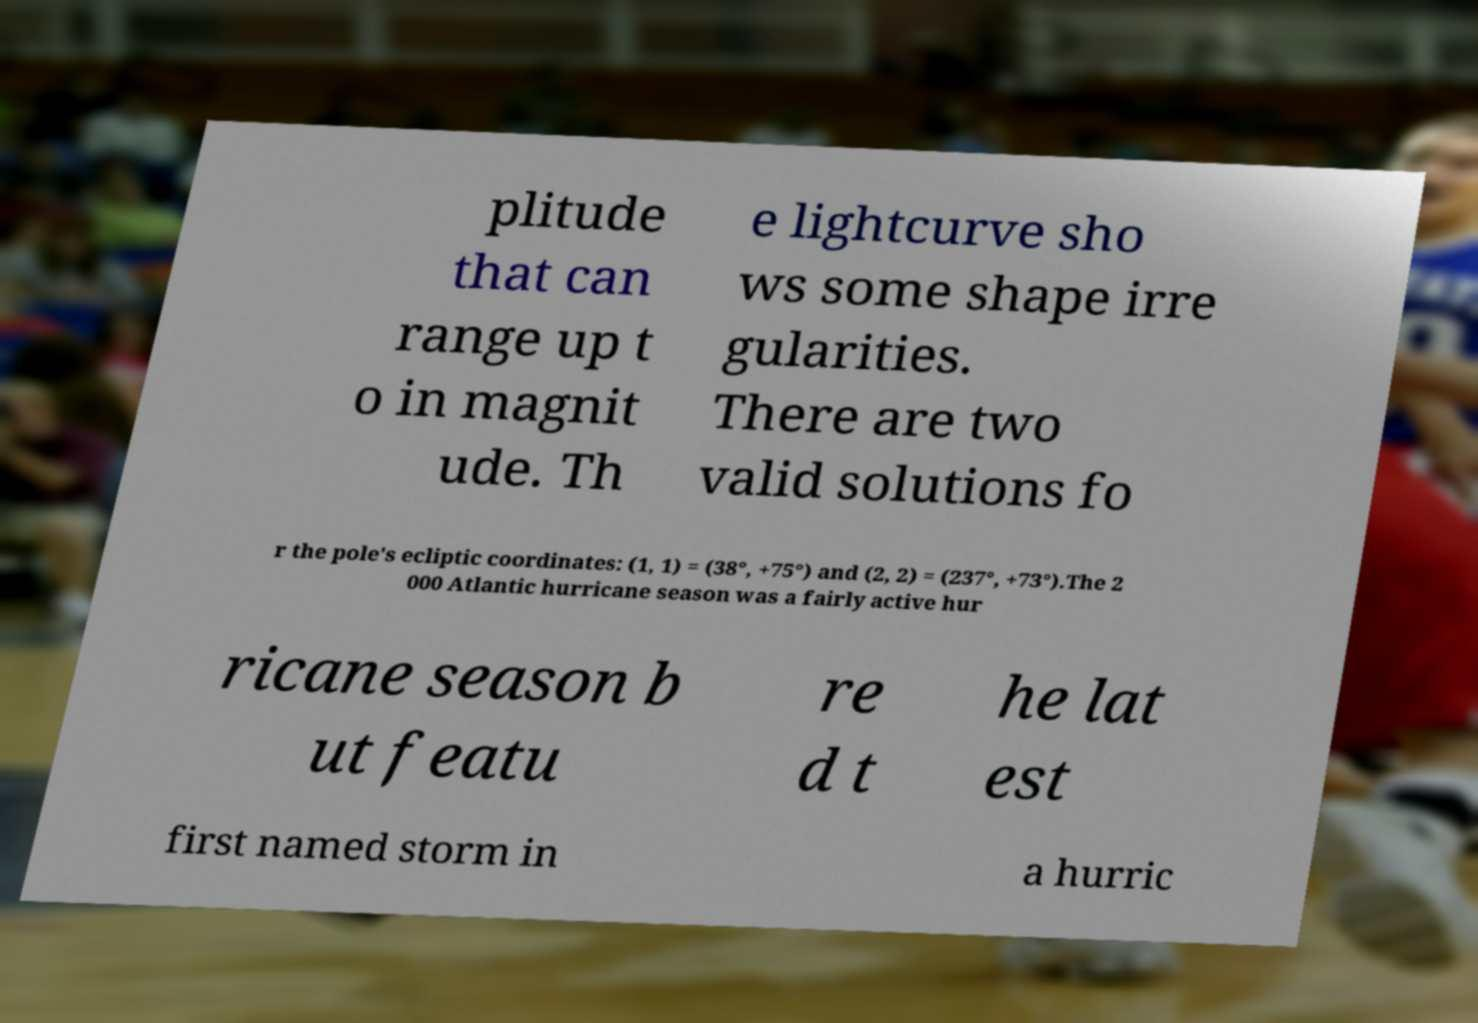Please identify and transcribe the text found in this image. plitude that can range up t o in magnit ude. Th e lightcurve sho ws some shape irre gularities. There are two valid solutions fo r the pole's ecliptic coordinates: (1, 1) = (38°, +75°) and (2, 2) = (237°, +73°).The 2 000 Atlantic hurricane season was a fairly active hur ricane season b ut featu re d t he lat est first named storm in a hurric 